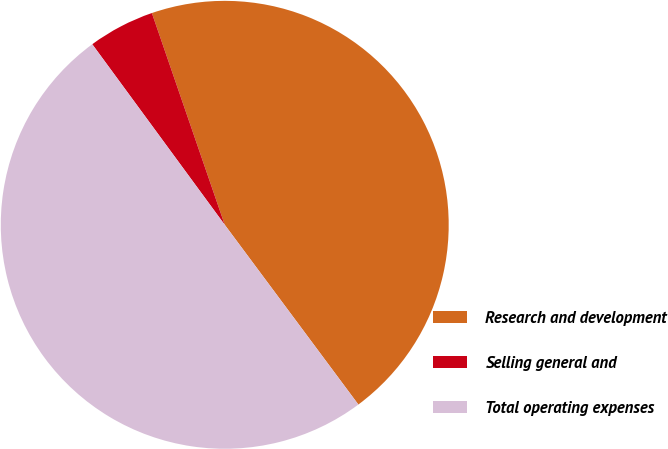<chart> <loc_0><loc_0><loc_500><loc_500><pie_chart><fcel>Research and development<fcel>Selling general and<fcel>Total operating expenses<nl><fcel>45.1%<fcel>4.8%<fcel>50.1%<nl></chart> 